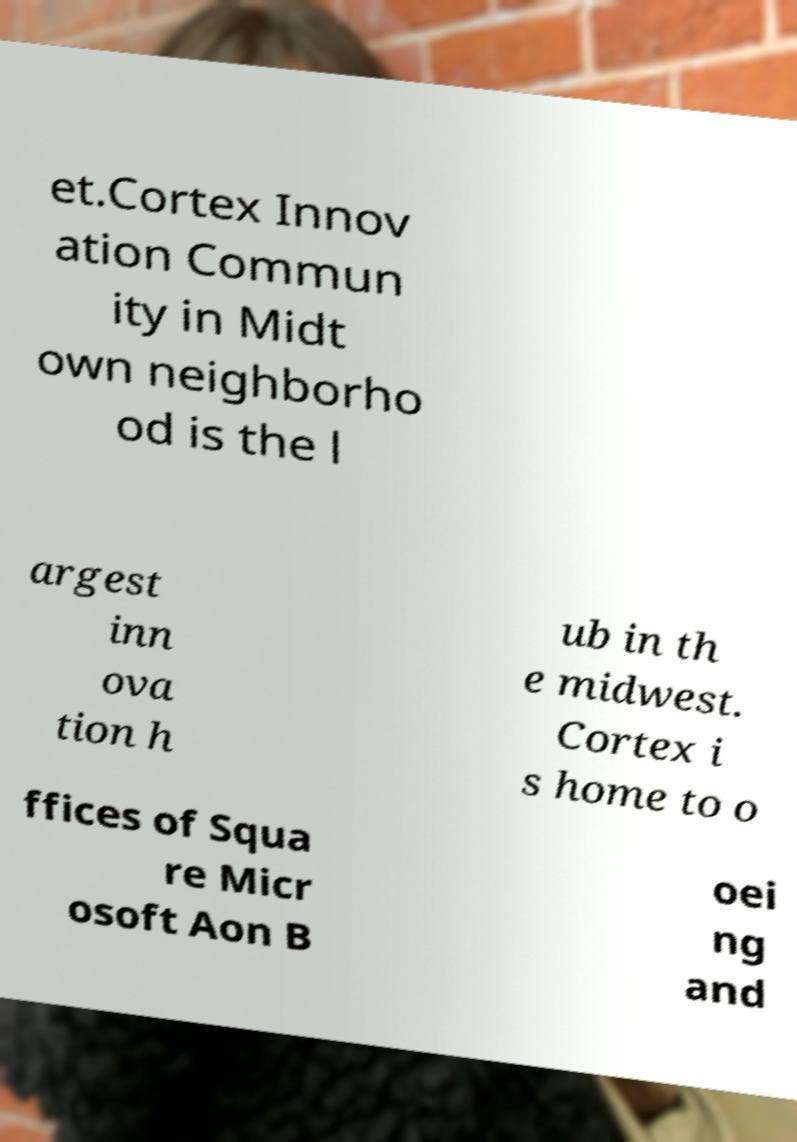Could you assist in decoding the text presented in this image and type it out clearly? et.Cortex Innov ation Commun ity in Midt own neighborho od is the l argest inn ova tion h ub in th e midwest. Cortex i s home to o ffices of Squa re Micr osoft Aon B oei ng and 